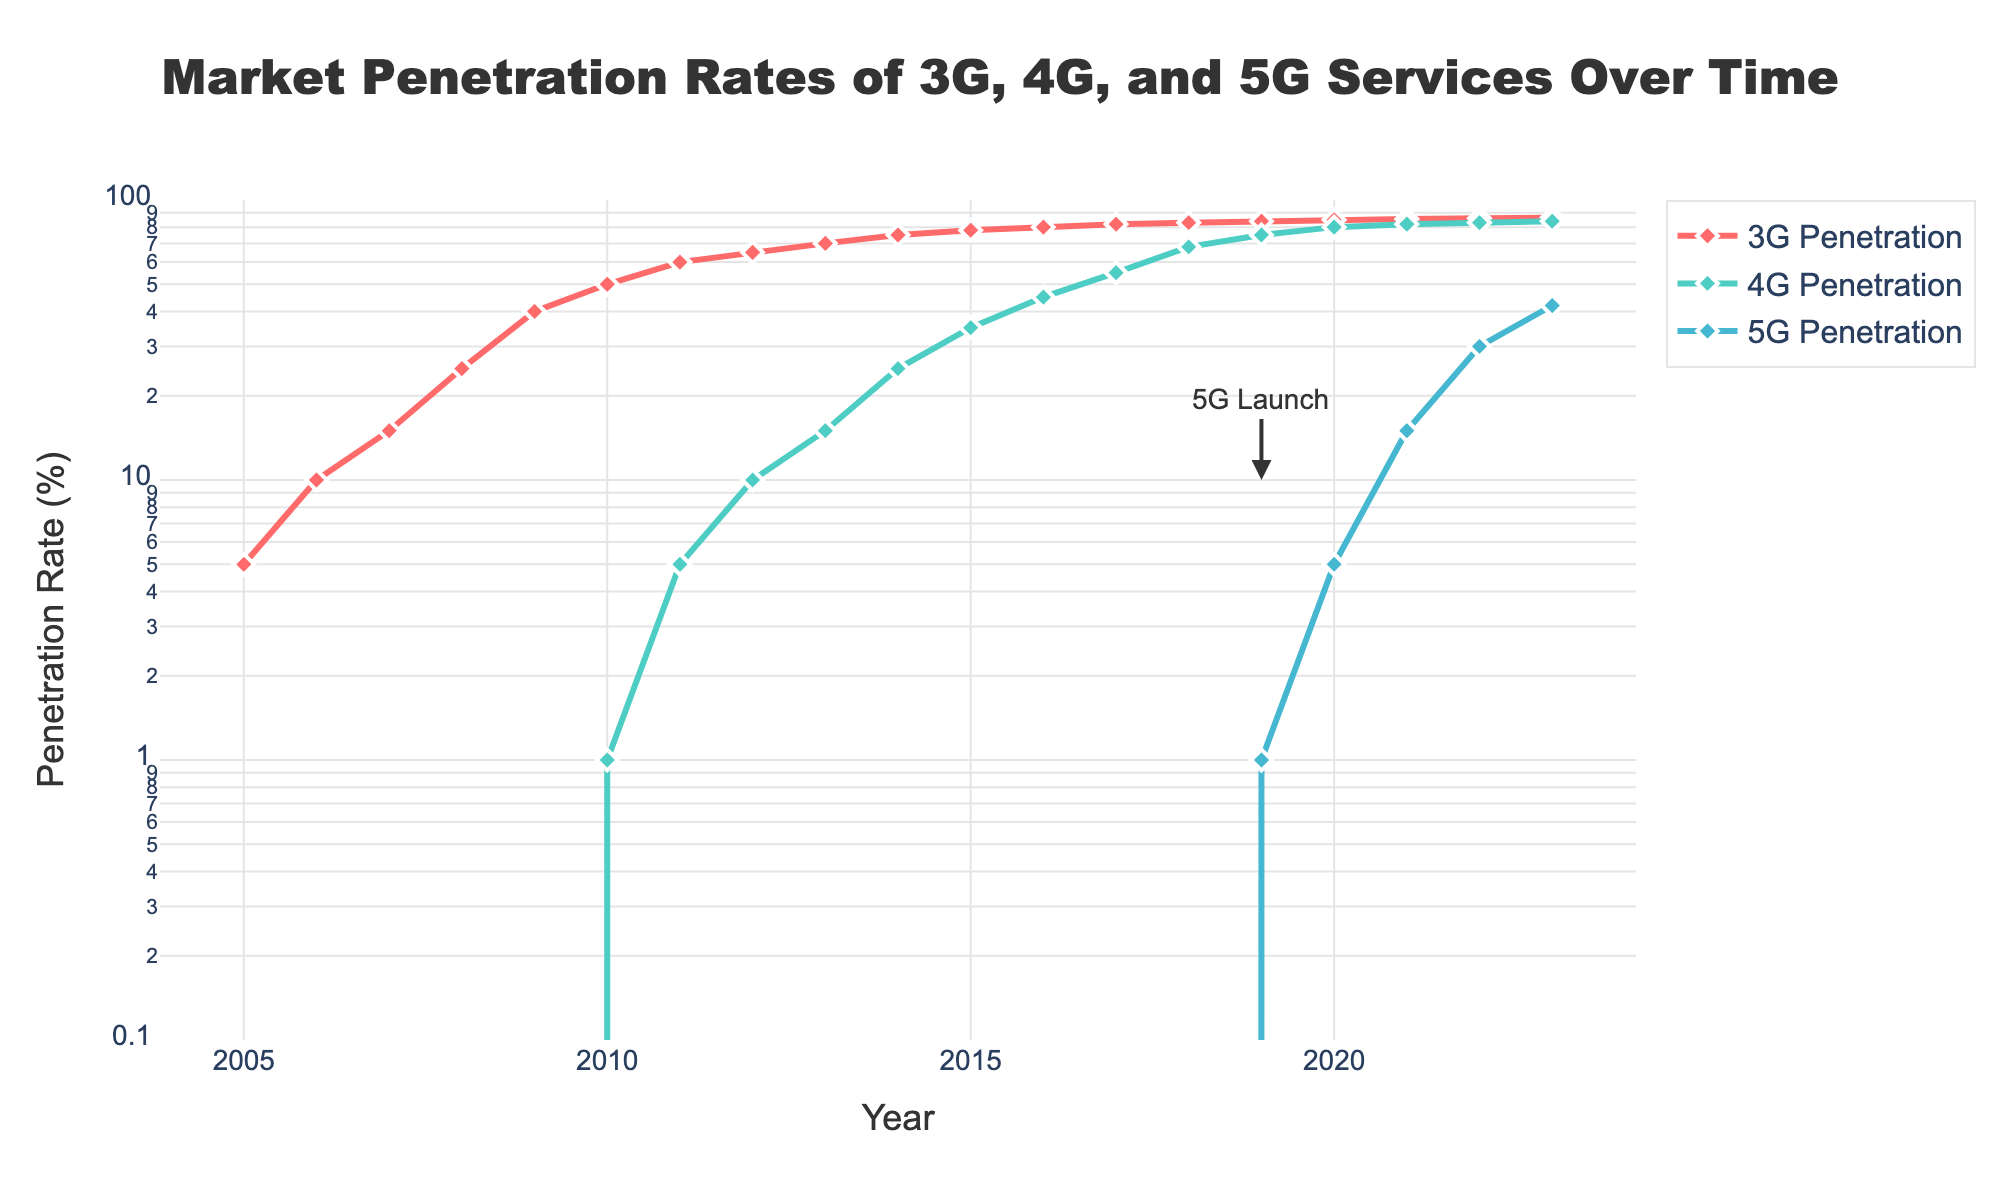What is the title of the figure? The title is usually the text at the top of the plot. Looking at the top center of the figure, we see "Market Penetration Rates of 3G, 4G, and 5G Services Over Time".
Answer: Market Penetration Rates of 3G, 4G, and 5G Services Over Time What does the y-axis represent? We can see from the title along the y-axis that it represents "Penetration Rate (%)".
Answer: Penetration Rate (%) Which year shows the first recorded value for 4G Penetration? By observing the plot and tracing the first appearance of a non-zero 4G Penetration rate, we find it starts in 2010.
Answer: 2010 What is the Penetration Rate of 5G in 2023? Look at the figure, follow the 5G line till the year 2023 on the x-axis. The corresponding y-axis value gives the penetration rate.
Answer: 42% Compare the penetration rates of 4G and 5G in 2022. Which one is higher? Follow both the 4G and 5G lines to the year 2022. The value corresponding to the 4G line is 83%, and for 5G it is 30%. Thus, 4G has a higher penetration rate.
Answer: 4G What is the difference in 3G penetration between 2009 and 2014? The y-axis value for 3G in 2009 is 40% and in 2014 is 75%. The difference is 75% - 40% = 35%.
Answer: 35% When was the 5G service launched according to the figure? There is an annotation in the plot pointing to the year 2019 marked as "5G Launch".
Answer: 2019 How do the trends of 3G and 4G penetration compare between 2010 and 2019? Both lines can be traced from 2010 to 2019. For 3G, it shows a slow increase and levels off around 85%. For 4G, it shows a rapid increase from 1% to 75%.
Answer: 3G is slow and levels off, 4G has rapid growth What is the y-axis scale and what range does it cover? The y-axis is a log scale covering from 0.1 (10^-1) to 100 (10^2) as seen in the axis ticks and labels.
Answer: Log scale, 0.1 to 100 